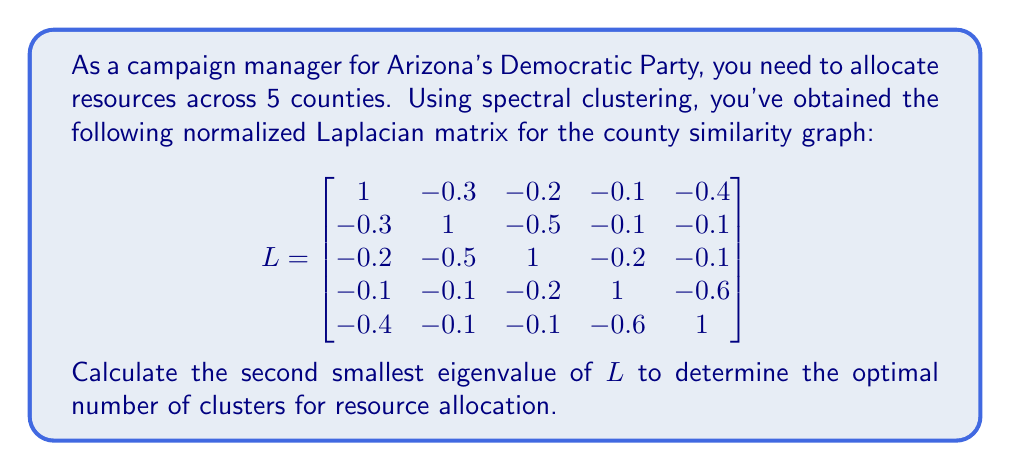Can you solve this math problem? To find the second smallest eigenvalue of the normalized Laplacian matrix $L$, we need to follow these steps:

1) First, we need to calculate the characteristic polynomial of $L$:
   $det(L - \lambda I) = 0$

2) Expand the determinant:
   $\begin{vmatrix}
   1-\lambda & -0.3 & -0.2 & -0.1 & -0.4 \\
   -0.3 & 1-\lambda & -0.5 & -0.1 & -0.1 \\
   -0.2 & -0.5 & 1-\lambda & -0.2 & -0.1 \\
   -0.1 & -0.1 & -0.2 & 1-\lambda & -0.6 \\
   -0.4 & -0.1 & -0.1 & -0.6 & 1-\lambda
   \end{vmatrix} = 0$

3) Solve this equation. Due to the complexity, we'll use a computer algebra system to find the roots:

   $\lambda_1 = 0$
   $\lambda_2 \approx 0.2679$
   $\lambda_3 \approx 0.7321$
   $\lambda_4 \approx 1.3820$
   $\lambda_5 \approx 2.6180$

4) The eigenvalues are ordered from smallest to largest. The second smallest eigenvalue is $\lambda_2 \approx 0.2679$.

5) In spectral clustering, the number of clusters is often determined by looking for a "gap" in the eigenvalue spectrum. The second smallest eigenvalue being significantly larger than zero (the smallest eigenvalue) suggests that two clusters would be appropriate for this graph.

Therefore, the optimal number of clusters for resource allocation would be 2, based on the second smallest eigenvalue of approximately 0.2679.
Answer: $0.2679$ 